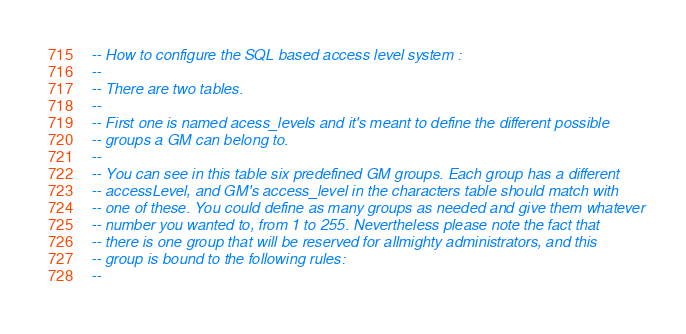Convert code to text. <code><loc_0><loc_0><loc_500><loc_500><_SQL_>-- How to configure the SQL based access level system :
--
-- There are two tables.
--
-- First one is named acess_levels and it's meant to define the different possible
-- groups a GM can belong to.
--
-- You can see in this table six predefined GM groups. Each group has a different
-- accessLevel, and GM's access_level in the characters table should match with
-- one of these. You could define as many groups as needed and give them whatever
-- number you wanted to, from 1 to 255. Nevertheless please note the fact that
-- there is one group that will be reserved for allmighty administrators, and this
-- group is bound to the following rules:
--</code> 